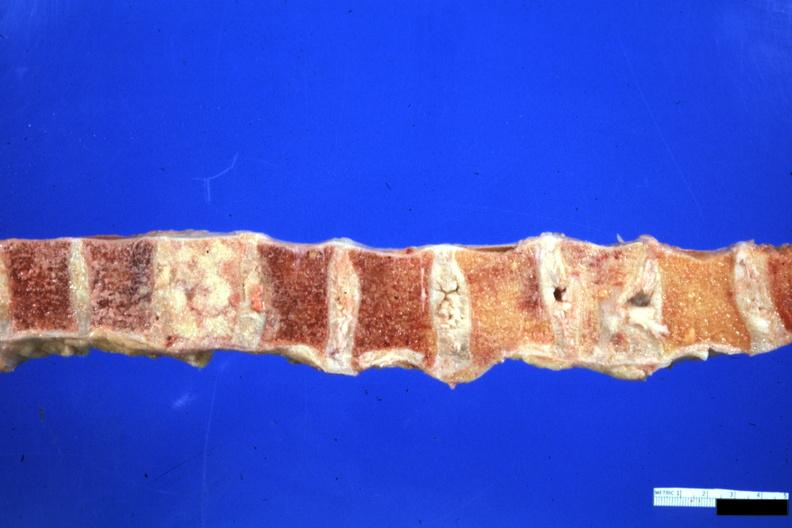what collapsed vertebra and one filled with neoplasm looks like breast carcinoma but is an unclassified lymphoma?
Answer the question using a single word or phrase. One 